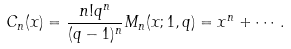Convert formula to latex. <formula><loc_0><loc_0><loc_500><loc_500>C _ { n } ( x ) = \frac { n ! q ^ { n } } { ( q - 1 ) ^ { n } } M _ { n } ( x ; 1 , q ) = x ^ { n } + \cdots .</formula> 